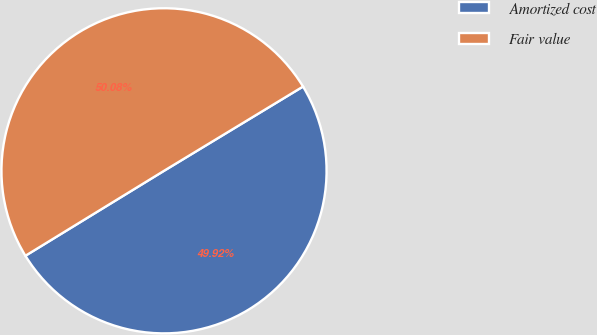Convert chart. <chart><loc_0><loc_0><loc_500><loc_500><pie_chart><fcel>Amortized cost<fcel>Fair value<nl><fcel>49.92%<fcel>50.08%<nl></chart> 